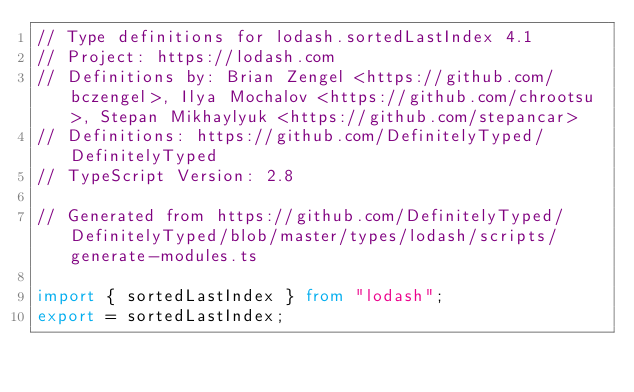Convert code to text. <code><loc_0><loc_0><loc_500><loc_500><_TypeScript_>// Type definitions for lodash.sortedLastIndex 4.1
// Project: https://lodash.com
// Definitions by: Brian Zengel <https://github.com/bczengel>, Ilya Mochalov <https://github.com/chrootsu>, Stepan Mikhaylyuk <https://github.com/stepancar>
// Definitions: https://github.com/DefinitelyTyped/DefinitelyTyped
// TypeScript Version: 2.8

// Generated from https://github.com/DefinitelyTyped/DefinitelyTyped/blob/master/types/lodash/scripts/generate-modules.ts

import { sortedLastIndex } from "lodash";
export = sortedLastIndex;
</code> 